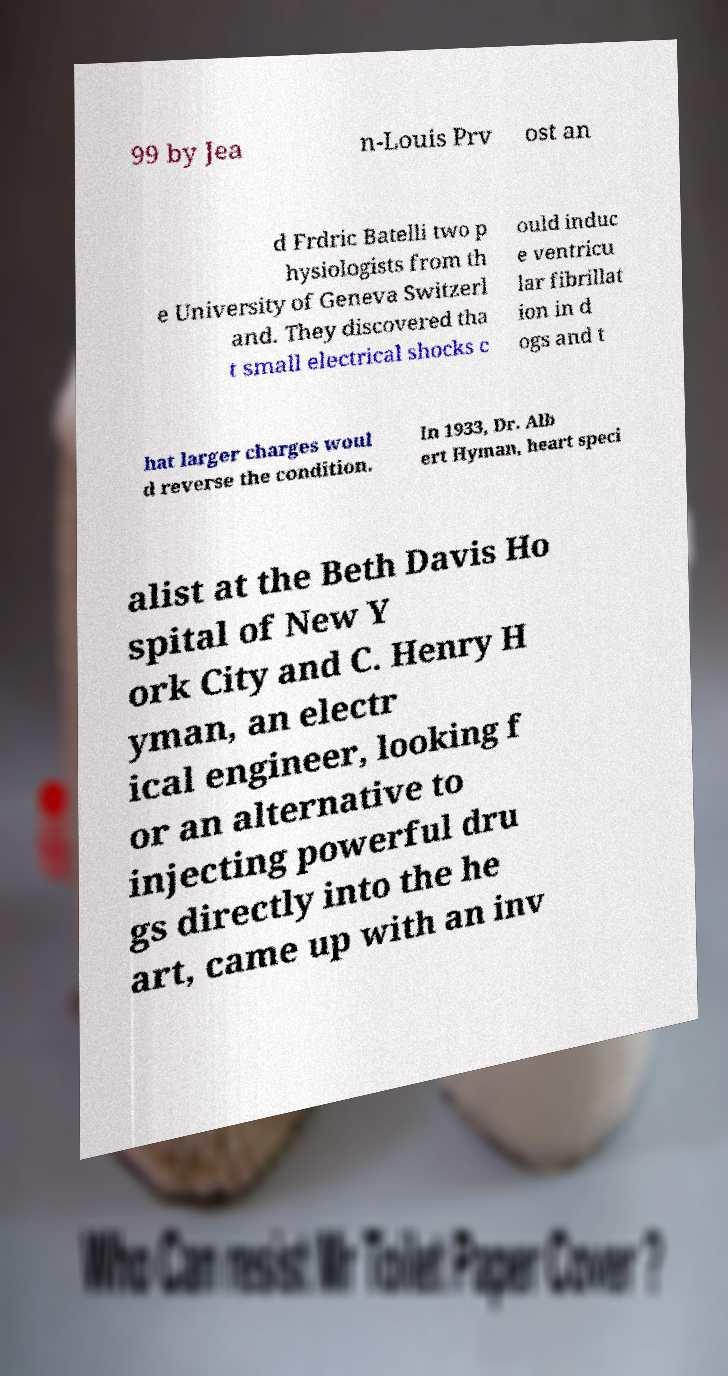What messages or text are displayed in this image? I need them in a readable, typed format. 99 by Jea n-Louis Prv ost an d Frdric Batelli two p hysiologists from th e University of Geneva Switzerl and. They discovered tha t small electrical shocks c ould induc e ventricu lar fibrillat ion in d ogs and t hat larger charges woul d reverse the condition. In 1933, Dr. Alb ert Hyman, heart speci alist at the Beth Davis Ho spital of New Y ork City and C. Henry H yman, an electr ical engineer, looking f or an alternative to injecting powerful dru gs directly into the he art, came up with an inv 